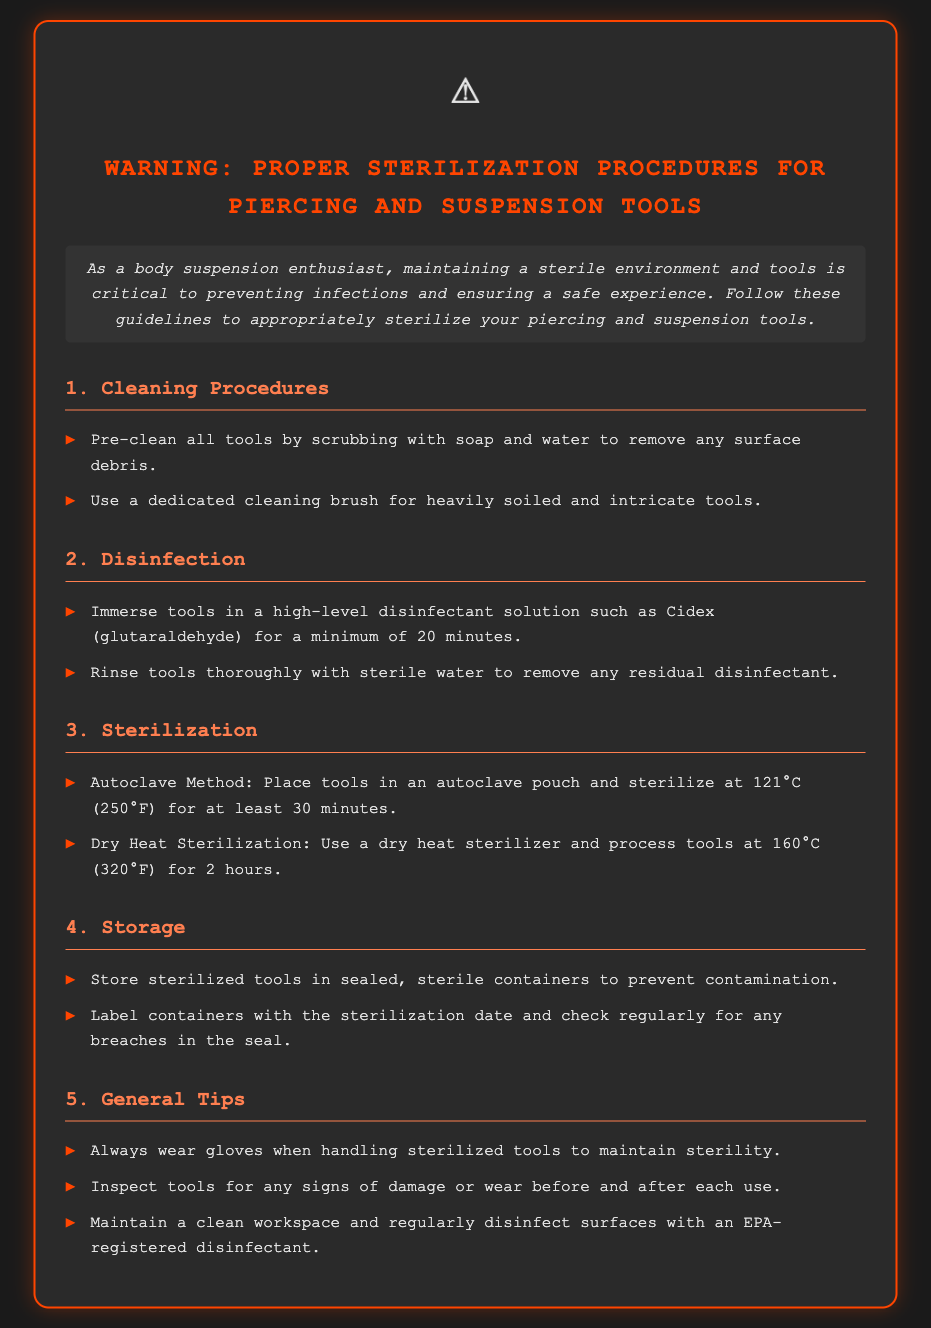What is the minimum temperature for autoclave sterilization? The document states that the temperature for autoclave sterilization is 121°C.
Answer: 121°C How long should tools be immersed in a disinfectant solution? According to the guidelines, tools should be immersed in the disinfectant for a minimum of 20 minutes.
Answer: 20 minutes What must be checked regularly for breaches? The document indicates that containers should be checked regularly for any breaches in the seal.
Answer: Seal What should you use to clean heavily soiled tools? It specifies using a dedicated cleaning brush for heavily soiled and intricate tools.
Answer: Cleaning brush What is the temperature used in dry heat sterilization? The document states that dry heat sterilization is done at 160°C.
Answer: 160°C Why is it important to wear gloves when handling sterilized tools? Wearing gloves helps maintain the sterility of the tools during handling.
Answer: Maintain sterility What should be stored in sealed, sterile containers? The document states that sterilized tools should be stored in sealed, sterile containers.
Answer: Sterilized tools What type of disinfectant should be used for tool disinfection? The guidelines mention using a high-level disinfectant solution such as Cidex (glutaraldehyde).
Answer: Cidex (glutaraldehyde) How long should tools be processed in a dry heat sterilizer? It specifies that tools should be processed at 160°C for 2 hours.
Answer: 2 hours 